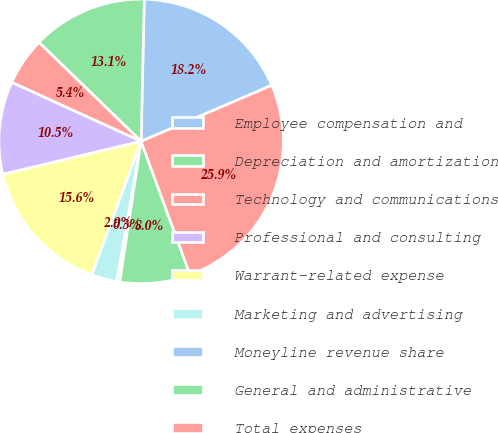Convert chart. <chart><loc_0><loc_0><loc_500><loc_500><pie_chart><fcel>Employee compensation and<fcel>Depreciation and amortization<fcel>Technology and communications<fcel>Professional and consulting<fcel>Warrant-related expense<fcel>Marketing and advertising<fcel>Moneyline revenue share<fcel>General and administrative<fcel>Total expenses<nl><fcel>18.2%<fcel>13.1%<fcel>5.44%<fcel>10.54%<fcel>15.65%<fcel>2.89%<fcel>0.34%<fcel>7.99%<fcel>25.86%<nl></chart> 